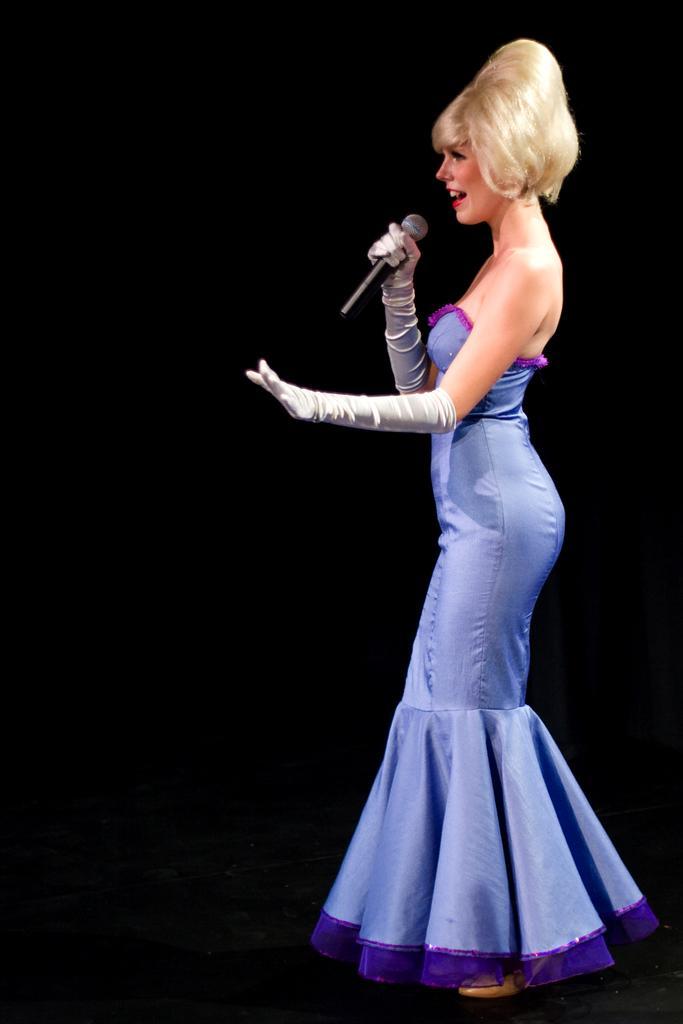Could you give a brief overview of what you see in this image? In this image we can see a lady standing and holding a mic. 